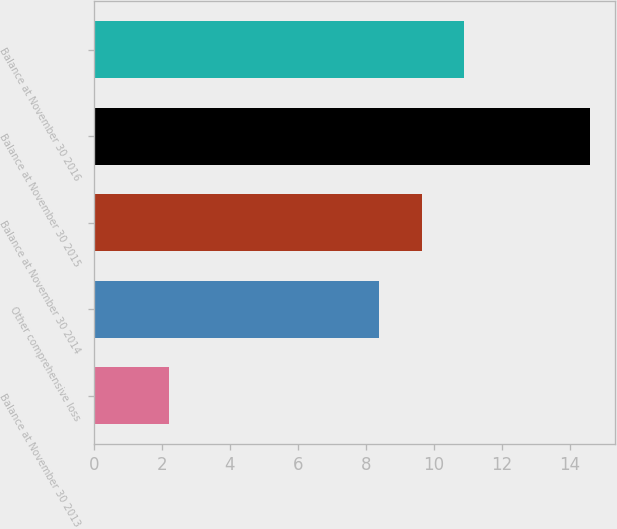<chart> <loc_0><loc_0><loc_500><loc_500><bar_chart><fcel>Balance at November 30 2013<fcel>Other comprehensive loss<fcel>Balance at November 30 2014<fcel>Balance at November 30 2015<fcel>Balance at November 30 2016<nl><fcel>2.2<fcel>8.4<fcel>9.64<fcel>14.6<fcel>10.88<nl></chart> 